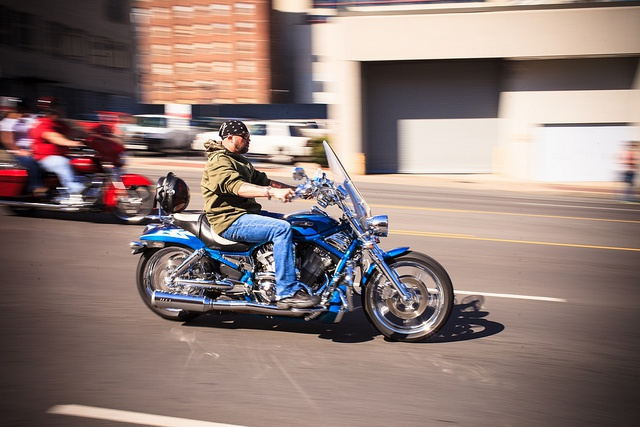Describe the objects in this image and their specific colors. I can see motorcycle in black, gray, lightgray, and darkgray tones, people in black, tan, white, and lightblue tones, motorcycle in black, gray, maroon, and red tones, people in black, red, lavender, and maroon tones, and car in black, white, gray, darkgray, and olive tones in this image. 